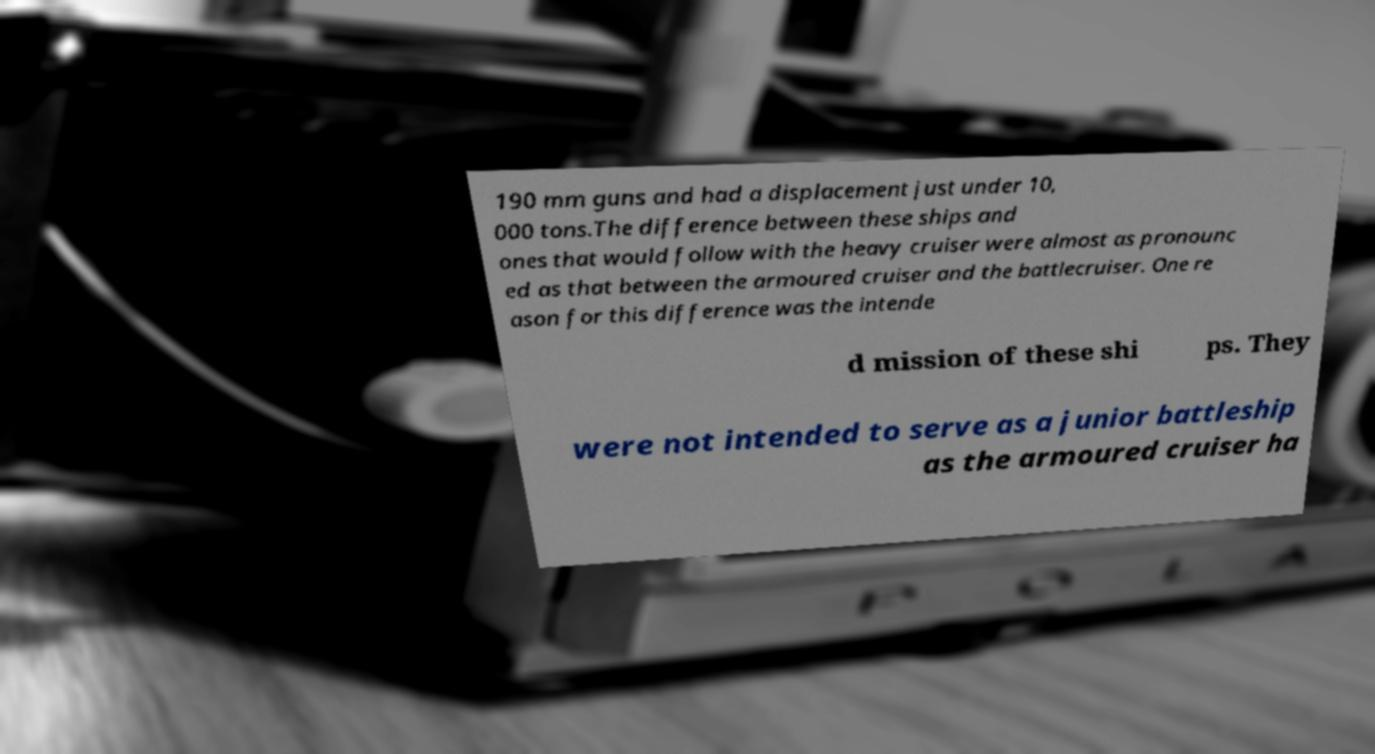There's text embedded in this image that I need extracted. Can you transcribe it verbatim? 190 mm guns and had a displacement just under 10, 000 tons.The difference between these ships and ones that would follow with the heavy cruiser were almost as pronounc ed as that between the armoured cruiser and the battlecruiser. One re ason for this difference was the intende d mission of these shi ps. They were not intended to serve as a junior battleship as the armoured cruiser ha 